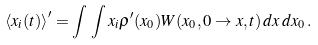Convert formula to latex. <formula><loc_0><loc_0><loc_500><loc_500>\left \langle x _ { i } ( t ) \right \rangle ^ { \prime } = \int \, \int x _ { i } \rho ^ { \prime } ( { x } _ { 0 } ) W ( { x } _ { 0 } , 0 \to { x } , t ) \, d { x } \, d { x } _ { 0 } \, .</formula> 